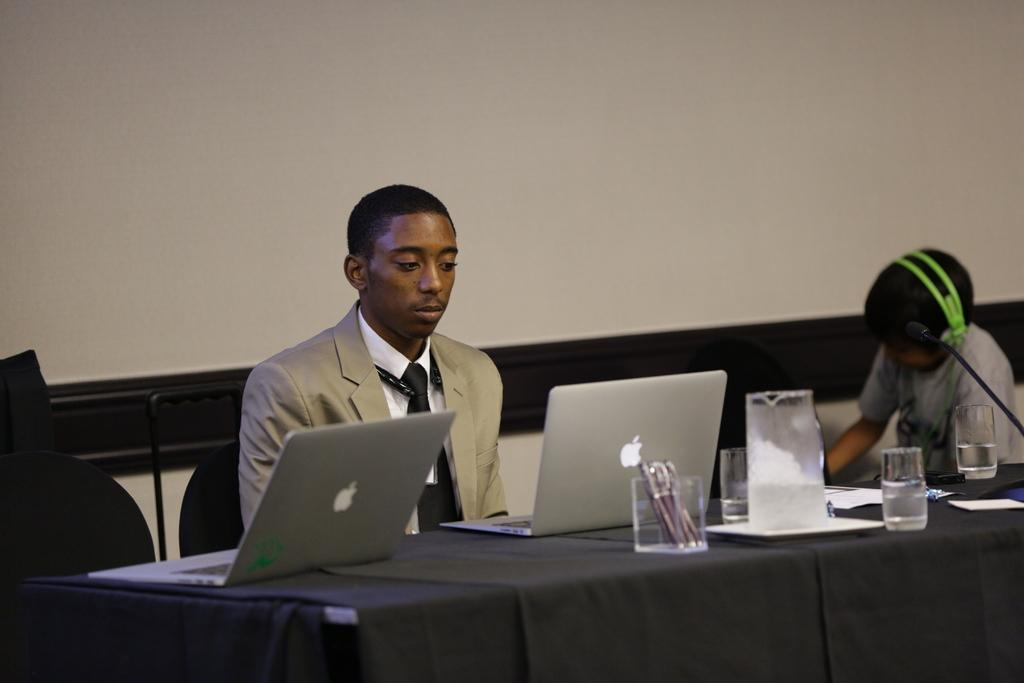How many people are in the image? There are two persons in the image. What are the two persons doing in the image? The two persons are sitting on a chair. What can be seen on the table in the image? There is a laptop, a glass, and a pen box on the table. What type of pest can be seen crawling on the laptop in the image? There are no pests visible in the image, and the laptop is not being crawled on by any creature. 